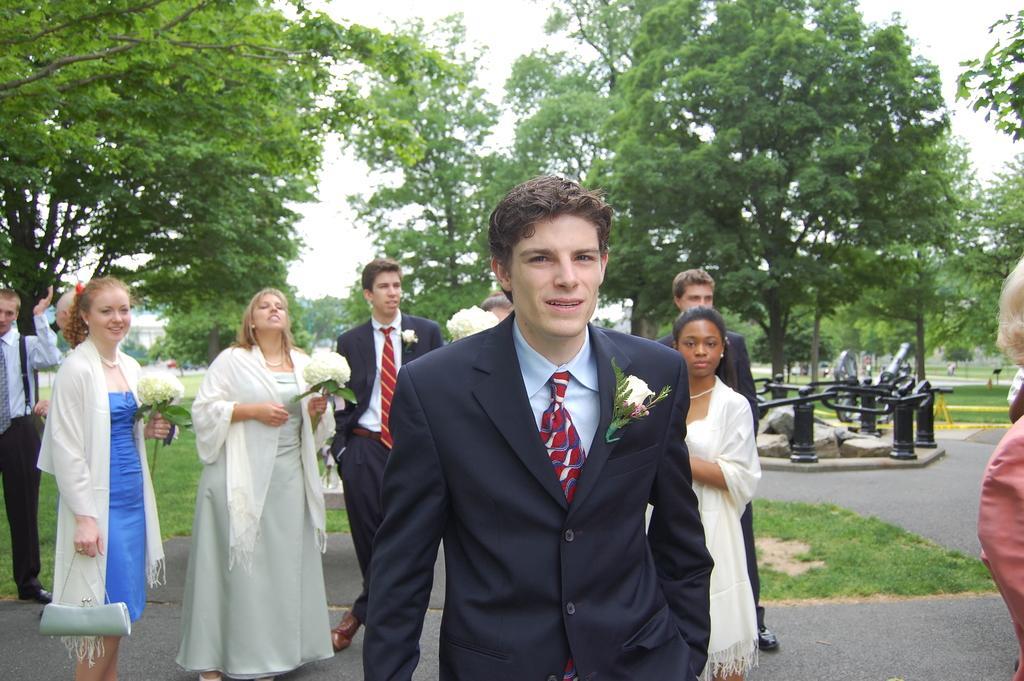Could you give a brief overview of what you see in this image? In this picture there is a boy wearing a black color suit and giving a pose into the camera. Behind there is a group of men and women holding the white flowers in the hand and giving a pose. In the background we can see some trees. 